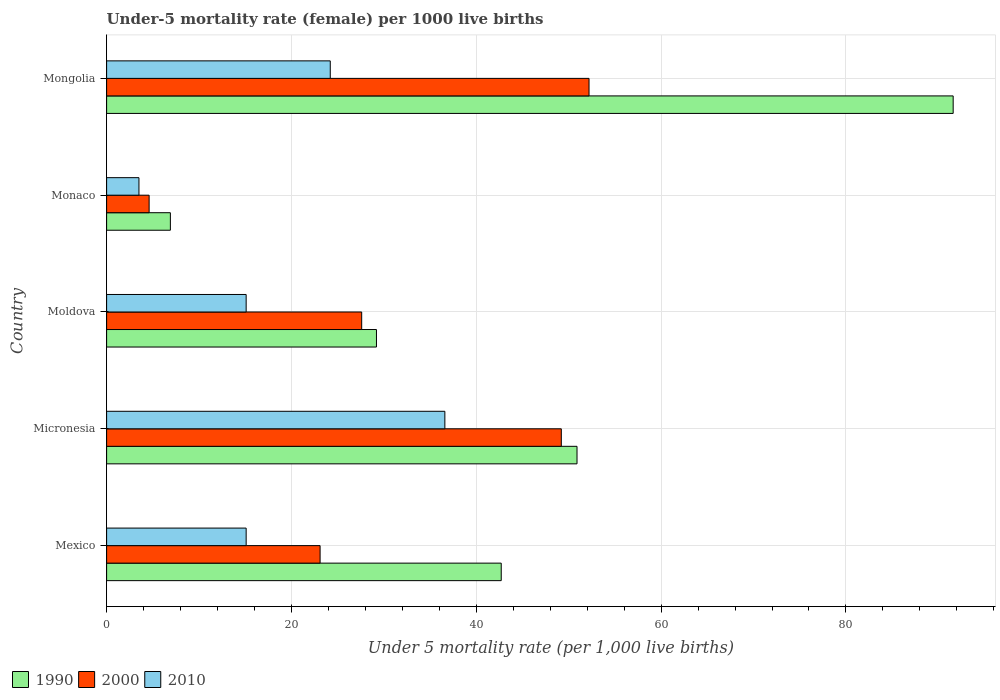How many different coloured bars are there?
Your answer should be very brief. 3. How many bars are there on the 4th tick from the top?
Your response must be concise. 3. How many bars are there on the 4th tick from the bottom?
Your response must be concise. 3. What is the label of the 3rd group of bars from the top?
Offer a terse response. Moldova. What is the under-five mortality rate in 1990 in Micronesia?
Provide a short and direct response. 50.9. Across all countries, what is the maximum under-five mortality rate in 1990?
Keep it short and to the point. 91.6. Across all countries, what is the minimum under-five mortality rate in 2000?
Your answer should be compact. 4.6. In which country was the under-five mortality rate in 2000 maximum?
Your answer should be compact. Mongolia. In which country was the under-five mortality rate in 1990 minimum?
Provide a short and direct response. Monaco. What is the total under-five mortality rate in 2000 in the graph?
Provide a succinct answer. 156.7. What is the difference between the under-five mortality rate in 2000 in Micronesia and that in Monaco?
Provide a short and direct response. 44.6. What is the difference between the under-five mortality rate in 1990 in Monaco and the under-five mortality rate in 2010 in Micronesia?
Offer a terse response. -29.7. What is the average under-five mortality rate in 2000 per country?
Ensure brevity in your answer.  31.34. What is the difference between the under-five mortality rate in 2000 and under-five mortality rate in 2010 in Micronesia?
Offer a terse response. 12.6. In how many countries, is the under-five mortality rate in 2000 greater than 32 ?
Offer a very short reply. 2. What is the ratio of the under-five mortality rate in 1990 in Moldova to that in Mongolia?
Your answer should be compact. 0.32. Is the under-five mortality rate in 2000 in Mexico less than that in Mongolia?
Provide a succinct answer. Yes. Is the difference between the under-five mortality rate in 2000 in Micronesia and Monaco greater than the difference between the under-five mortality rate in 2010 in Micronesia and Monaco?
Provide a short and direct response. Yes. What is the difference between the highest and the lowest under-five mortality rate in 1990?
Make the answer very short. 84.7. Is the sum of the under-five mortality rate in 1990 in Micronesia and Mongolia greater than the maximum under-five mortality rate in 2010 across all countries?
Give a very brief answer. Yes. What does the 1st bar from the top in Mongolia represents?
Give a very brief answer. 2010. What does the 3rd bar from the bottom in Moldova represents?
Offer a terse response. 2010. Is it the case that in every country, the sum of the under-five mortality rate in 2010 and under-five mortality rate in 2000 is greater than the under-five mortality rate in 1990?
Ensure brevity in your answer.  No. Are all the bars in the graph horizontal?
Ensure brevity in your answer.  Yes. Does the graph contain any zero values?
Ensure brevity in your answer.  No. How many legend labels are there?
Make the answer very short. 3. What is the title of the graph?
Your response must be concise. Under-5 mortality rate (female) per 1000 live births. What is the label or title of the X-axis?
Your response must be concise. Under 5 mortality rate (per 1,0 live births). What is the Under 5 mortality rate (per 1,000 live births) of 1990 in Mexico?
Provide a succinct answer. 42.7. What is the Under 5 mortality rate (per 1,000 live births) in 2000 in Mexico?
Your answer should be compact. 23.1. What is the Under 5 mortality rate (per 1,000 live births) in 1990 in Micronesia?
Offer a very short reply. 50.9. What is the Under 5 mortality rate (per 1,000 live births) of 2000 in Micronesia?
Offer a terse response. 49.2. What is the Under 5 mortality rate (per 1,000 live births) of 2010 in Micronesia?
Provide a succinct answer. 36.6. What is the Under 5 mortality rate (per 1,000 live births) of 1990 in Moldova?
Ensure brevity in your answer.  29.2. What is the Under 5 mortality rate (per 1,000 live births) of 2000 in Moldova?
Your answer should be compact. 27.6. What is the Under 5 mortality rate (per 1,000 live births) in 2010 in Moldova?
Make the answer very short. 15.1. What is the Under 5 mortality rate (per 1,000 live births) of 2000 in Monaco?
Give a very brief answer. 4.6. What is the Under 5 mortality rate (per 1,000 live births) of 1990 in Mongolia?
Your answer should be compact. 91.6. What is the Under 5 mortality rate (per 1,000 live births) of 2000 in Mongolia?
Offer a very short reply. 52.2. What is the Under 5 mortality rate (per 1,000 live births) of 2010 in Mongolia?
Provide a succinct answer. 24.2. Across all countries, what is the maximum Under 5 mortality rate (per 1,000 live births) of 1990?
Provide a succinct answer. 91.6. Across all countries, what is the maximum Under 5 mortality rate (per 1,000 live births) of 2000?
Provide a short and direct response. 52.2. Across all countries, what is the maximum Under 5 mortality rate (per 1,000 live births) in 2010?
Provide a short and direct response. 36.6. Across all countries, what is the minimum Under 5 mortality rate (per 1,000 live births) of 2010?
Your answer should be very brief. 3.5. What is the total Under 5 mortality rate (per 1,000 live births) of 1990 in the graph?
Provide a short and direct response. 221.3. What is the total Under 5 mortality rate (per 1,000 live births) of 2000 in the graph?
Make the answer very short. 156.7. What is the total Under 5 mortality rate (per 1,000 live births) of 2010 in the graph?
Give a very brief answer. 94.5. What is the difference between the Under 5 mortality rate (per 1,000 live births) in 1990 in Mexico and that in Micronesia?
Keep it short and to the point. -8.2. What is the difference between the Under 5 mortality rate (per 1,000 live births) of 2000 in Mexico and that in Micronesia?
Offer a very short reply. -26.1. What is the difference between the Under 5 mortality rate (per 1,000 live births) in 2010 in Mexico and that in Micronesia?
Make the answer very short. -21.5. What is the difference between the Under 5 mortality rate (per 1,000 live births) in 1990 in Mexico and that in Moldova?
Offer a terse response. 13.5. What is the difference between the Under 5 mortality rate (per 1,000 live births) of 2010 in Mexico and that in Moldova?
Provide a succinct answer. 0. What is the difference between the Under 5 mortality rate (per 1,000 live births) of 1990 in Mexico and that in Monaco?
Provide a succinct answer. 35.8. What is the difference between the Under 5 mortality rate (per 1,000 live births) of 2010 in Mexico and that in Monaco?
Offer a very short reply. 11.6. What is the difference between the Under 5 mortality rate (per 1,000 live births) in 1990 in Mexico and that in Mongolia?
Your answer should be compact. -48.9. What is the difference between the Under 5 mortality rate (per 1,000 live births) in 2000 in Mexico and that in Mongolia?
Provide a short and direct response. -29.1. What is the difference between the Under 5 mortality rate (per 1,000 live births) in 2010 in Mexico and that in Mongolia?
Offer a terse response. -9.1. What is the difference between the Under 5 mortality rate (per 1,000 live births) in 1990 in Micronesia and that in Moldova?
Your response must be concise. 21.7. What is the difference between the Under 5 mortality rate (per 1,000 live births) of 2000 in Micronesia and that in Moldova?
Offer a very short reply. 21.6. What is the difference between the Under 5 mortality rate (per 1,000 live births) in 1990 in Micronesia and that in Monaco?
Ensure brevity in your answer.  44. What is the difference between the Under 5 mortality rate (per 1,000 live births) in 2000 in Micronesia and that in Monaco?
Offer a terse response. 44.6. What is the difference between the Under 5 mortality rate (per 1,000 live births) of 2010 in Micronesia and that in Monaco?
Your response must be concise. 33.1. What is the difference between the Under 5 mortality rate (per 1,000 live births) in 1990 in Micronesia and that in Mongolia?
Give a very brief answer. -40.7. What is the difference between the Under 5 mortality rate (per 1,000 live births) of 2000 in Micronesia and that in Mongolia?
Offer a very short reply. -3. What is the difference between the Under 5 mortality rate (per 1,000 live births) of 1990 in Moldova and that in Monaco?
Ensure brevity in your answer.  22.3. What is the difference between the Under 5 mortality rate (per 1,000 live births) of 2010 in Moldova and that in Monaco?
Keep it short and to the point. 11.6. What is the difference between the Under 5 mortality rate (per 1,000 live births) in 1990 in Moldova and that in Mongolia?
Keep it short and to the point. -62.4. What is the difference between the Under 5 mortality rate (per 1,000 live births) of 2000 in Moldova and that in Mongolia?
Provide a succinct answer. -24.6. What is the difference between the Under 5 mortality rate (per 1,000 live births) of 1990 in Monaco and that in Mongolia?
Keep it short and to the point. -84.7. What is the difference between the Under 5 mortality rate (per 1,000 live births) of 2000 in Monaco and that in Mongolia?
Offer a very short reply. -47.6. What is the difference between the Under 5 mortality rate (per 1,000 live births) in 2010 in Monaco and that in Mongolia?
Your response must be concise. -20.7. What is the difference between the Under 5 mortality rate (per 1,000 live births) of 1990 in Mexico and the Under 5 mortality rate (per 1,000 live births) of 2010 in Micronesia?
Provide a short and direct response. 6.1. What is the difference between the Under 5 mortality rate (per 1,000 live births) in 2000 in Mexico and the Under 5 mortality rate (per 1,000 live births) in 2010 in Micronesia?
Offer a terse response. -13.5. What is the difference between the Under 5 mortality rate (per 1,000 live births) in 1990 in Mexico and the Under 5 mortality rate (per 1,000 live births) in 2000 in Moldova?
Ensure brevity in your answer.  15.1. What is the difference between the Under 5 mortality rate (per 1,000 live births) in 1990 in Mexico and the Under 5 mortality rate (per 1,000 live births) in 2010 in Moldova?
Provide a short and direct response. 27.6. What is the difference between the Under 5 mortality rate (per 1,000 live births) of 1990 in Mexico and the Under 5 mortality rate (per 1,000 live births) of 2000 in Monaco?
Your response must be concise. 38.1. What is the difference between the Under 5 mortality rate (per 1,000 live births) in 1990 in Mexico and the Under 5 mortality rate (per 1,000 live births) in 2010 in Monaco?
Your answer should be very brief. 39.2. What is the difference between the Under 5 mortality rate (per 1,000 live births) in 2000 in Mexico and the Under 5 mortality rate (per 1,000 live births) in 2010 in Monaco?
Make the answer very short. 19.6. What is the difference between the Under 5 mortality rate (per 1,000 live births) of 2000 in Mexico and the Under 5 mortality rate (per 1,000 live births) of 2010 in Mongolia?
Keep it short and to the point. -1.1. What is the difference between the Under 5 mortality rate (per 1,000 live births) of 1990 in Micronesia and the Under 5 mortality rate (per 1,000 live births) of 2000 in Moldova?
Keep it short and to the point. 23.3. What is the difference between the Under 5 mortality rate (per 1,000 live births) in 1990 in Micronesia and the Under 5 mortality rate (per 1,000 live births) in 2010 in Moldova?
Offer a very short reply. 35.8. What is the difference between the Under 5 mortality rate (per 1,000 live births) in 2000 in Micronesia and the Under 5 mortality rate (per 1,000 live births) in 2010 in Moldova?
Make the answer very short. 34.1. What is the difference between the Under 5 mortality rate (per 1,000 live births) of 1990 in Micronesia and the Under 5 mortality rate (per 1,000 live births) of 2000 in Monaco?
Ensure brevity in your answer.  46.3. What is the difference between the Under 5 mortality rate (per 1,000 live births) of 1990 in Micronesia and the Under 5 mortality rate (per 1,000 live births) of 2010 in Monaco?
Provide a short and direct response. 47.4. What is the difference between the Under 5 mortality rate (per 1,000 live births) of 2000 in Micronesia and the Under 5 mortality rate (per 1,000 live births) of 2010 in Monaco?
Keep it short and to the point. 45.7. What is the difference between the Under 5 mortality rate (per 1,000 live births) of 1990 in Micronesia and the Under 5 mortality rate (per 1,000 live births) of 2010 in Mongolia?
Provide a succinct answer. 26.7. What is the difference between the Under 5 mortality rate (per 1,000 live births) of 2000 in Micronesia and the Under 5 mortality rate (per 1,000 live births) of 2010 in Mongolia?
Ensure brevity in your answer.  25. What is the difference between the Under 5 mortality rate (per 1,000 live births) of 1990 in Moldova and the Under 5 mortality rate (per 1,000 live births) of 2000 in Monaco?
Offer a terse response. 24.6. What is the difference between the Under 5 mortality rate (per 1,000 live births) of 1990 in Moldova and the Under 5 mortality rate (per 1,000 live births) of 2010 in Monaco?
Offer a terse response. 25.7. What is the difference between the Under 5 mortality rate (per 1,000 live births) in 2000 in Moldova and the Under 5 mortality rate (per 1,000 live births) in 2010 in Monaco?
Make the answer very short. 24.1. What is the difference between the Under 5 mortality rate (per 1,000 live births) of 2000 in Moldova and the Under 5 mortality rate (per 1,000 live births) of 2010 in Mongolia?
Your answer should be compact. 3.4. What is the difference between the Under 5 mortality rate (per 1,000 live births) of 1990 in Monaco and the Under 5 mortality rate (per 1,000 live births) of 2000 in Mongolia?
Provide a succinct answer. -45.3. What is the difference between the Under 5 mortality rate (per 1,000 live births) of 1990 in Monaco and the Under 5 mortality rate (per 1,000 live births) of 2010 in Mongolia?
Offer a terse response. -17.3. What is the difference between the Under 5 mortality rate (per 1,000 live births) of 2000 in Monaco and the Under 5 mortality rate (per 1,000 live births) of 2010 in Mongolia?
Offer a terse response. -19.6. What is the average Under 5 mortality rate (per 1,000 live births) in 1990 per country?
Provide a short and direct response. 44.26. What is the average Under 5 mortality rate (per 1,000 live births) in 2000 per country?
Provide a succinct answer. 31.34. What is the difference between the Under 5 mortality rate (per 1,000 live births) of 1990 and Under 5 mortality rate (per 1,000 live births) of 2000 in Mexico?
Your response must be concise. 19.6. What is the difference between the Under 5 mortality rate (per 1,000 live births) of 1990 and Under 5 mortality rate (per 1,000 live births) of 2010 in Mexico?
Your answer should be compact. 27.6. What is the difference between the Under 5 mortality rate (per 1,000 live births) of 2000 and Under 5 mortality rate (per 1,000 live births) of 2010 in Mexico?
Your response must be concise. 8. What is the difference between the Under 5 mortality rate (per 1,000 live births) of 1990 and Under 5 mortality rate (per 1,000 live births) of 2000 in Micronesia?
Give a very brief answer. 1.7. What is the difference between the Under 5 mortality rate (per 1,000 live births) of 2000 and Under 5 mortality rate (per 1,000 live births) of 2010 in Micronesia?
Provide a succinct answer. 12.6. What is the difference between the Under 5 mortality rate (per 1,000 live births) of 2000 and Under 5 mortality rate (per 1,000 live births) of 2010 in Moldova?
Provide a short and direct response. 12.5. What is the difference between the Under 5 mortality rate (per 1,000 live births) in 1990 and Under 5 mortality rate (per 1,000 live births) in 2000 in Monaco?
Your response must be concise. 2.3. What is the difference between the Under 5 mortality rate (per 1,000 live births) in 1990 and Under 5 mortality rate (per 1,000 live births) in 2010 in Monaco?
Ensure brevity in your answer.  3.4. What is the difference between the Under 5 mortality rate (per 1,000 live births) in 1990 and Under 5 mortality rate (per 1,000 live births) in 2000 in Mongolia?
Make the answer very short. 39.4. What is the difference between the Under 5 mortality rate (per 1,000 live births) in 1990 and Under 5 mortality rate (per 1,000 live births) in 2010 in Mongolia?
Your answer should be compact. 67.4. What is the ratio of the Under 5 mortality rate (per 1,000 live births) in 1990 in Mexico to that in Micronesia?
Your answer should be very brief. 0.84. What is the ratio of the Under 5 mortality rate (per 1,000 live births) in 2000 in Mexico to that in Micronesia?
Make the answer very short. 0.47. What is the ratio of the Under 5 mortality rate (per 1,000 live births) in 2010 in Mexico to that in Micronesia?
Your answer should be very brief. 0.41. What is the ratio of the Under 5 mortality rate (per 1,000 live births) in 1990 in Mexico to that in Moldova?
Keep it short and to the point. 1.46. What is the ratio of the Under 5 mortality rate (per 1,000 live births) in 2000 in Mexico to that in Moldova?
Make the answer very short. 0.84. What is the ratio of the Under 5 mortality rate (per 1,000 live births) of 2010 in Mexico to that in Moldova?
Offer a very short reply. 1. What is the ratio of the Under 5 mortality rate (per 1,000 live births) of 1990 in Mexico to that in Monaco?
Ensure brevity in your answer.  6.19. What is the ratio of the Under 5 mortality rate (per 1,000 live births) of 2000 in Mexico to that in Monaco?
Give a very brief answer. 5.02. What is the ratio of the Under 5 mortality rate (per 1,000 live births) in 2010 in Mexico to that in Monaco?
Your response must be concise. 4.31. What is the ratio of the Under 5 mortality rate (per 1,000 live births) of 1990 in Mexico to that in Mongolia?
Your answer should be compact. 0.47. What is the ratio of the Under 5 mortality rate (per 1,000 live births) in 2000 in Mexico to that in Mongolia?
Ensure brevity in your answer.  0.44. What is the ratio of the Under 5 mortality rate (per 1,000 live births) of 2010 in Mexico to that in Mongolia?
Offer a very short reply. 0.62. What is the ratio of the Under 5 mortality rate (per 1,000 live births) of 1990 in Micronesia to that in Moldova?
Keep it short and to the point. 1.74. What is the ratio of the Under 5 mortality rate (per 1,000 live births) in 2000 in Micronesia to that in Moldova?
Give a very brief answer. 1.78. What is the ratio of the Under 5 mortality rate (per 1,000 live births) in 2010 in Micronesia to that in Moldova?
Keep it short and to the point. 2.42. What is the ratio of the Under 5 mortality rate (per 1,000 live births) of 1990 in Micronesia to that in Monaco?
Make the answer very short. 7.38. What is the ratio of the Under 5 mortality rate (per 1,000 live births) in 2000 in Micronesia to that in Monaco?
Make the answer very short. 10.7. What is the ratio of the Under 5 mortality rate (per 1,000 live births) of 2010 in Micronesia to that in Monaco?
Your answer should be compact. 10.46. What is the ratio of the Under 5 mortality rate (per 1,000 live births) of 1990 in Micronesia to that in Mongolia?
Make the answer very short. 0.56. What is the ratio of the Under 5 mortality rate (per 1,000 live births) of 2000 in Micronesia to that in Mongolia?
Ensure brevity in your answer.  0.94. What is the ratio of the Under 5 mortality rate (per 1,000 live births) of 2010 in Micronesia to that in Mongolia?
Offer a very short reply. 1.51. What is the ratio of the Under 5 mortality rate (per 1,000 live births) of 1990 in Moldova to that in Monaco?
Make the answer very short. 4.23. What is the ratio of the Under 5 mortality rate (per 1,000 live births) of 2010 in Moldova to that in Monaco?
Your answer should be compact. 4.31. What is the ratio of the Under 5 mortality rate (per 1,000 live births) in 1990 in Moldova to that in Mongolia?
Offer a terse response. 0.32. What is the ratio of the Under 5 mortality rate (per 1,000 live births) in 2000 in Moldova to that in Mongolia?
Make the answer very short. 0.53. What is the ratio of the Under 5 mortality rate (per 1,000 live births) of 2010 in Moldova to that in Mongolia?
Ensure brevity in your answer.  0.62. What is the ratio of the Under 5 mortality rate (per 1,000 live births) in 1990 in Monaco to that in Mongolia?
Provide a succinct answer. 0.08. What is the ratio of the Under 5 mortality rate (per 1,000 live births) of 2000 in Monaco to that in Mongolia?
Offer a very short reply. 0.09. What is the ratio of the Under 5 mortality rate (per 1,000 live births) of 2010 in Monaco to that in Mongolia?
Offer a terse response. 0.14. What is the difference between the highest and the second highest Under 5 mortality rate (per 1,000 live births) of 1990?
Provide a short and direct response. 40.7. What is the difference between the highest and the second highest Under 5 mortality rate (per 1,000 live births) in 2000?
Offer a terse response. 3. What is the difference between the highest and the second highest Under 5 mortality rate (per 1,000 live births) of 2010?
Your response must be concise. 12.4. What is the difference between the highest and the lowest Under 5 mortality rate (per 1,000 live births) of 1990?
Your answer should be compact. 84.7. What is the difference between the highest and the lowest Under 5 mortality rate (per 1,000 live births) of 2000?
Offer a terse response. 47.6. What is the difference between the highest and the lowest Under 5 mortality rate (per 1,000 live births) in 2010?
Your answer should be compact. 33.1. 